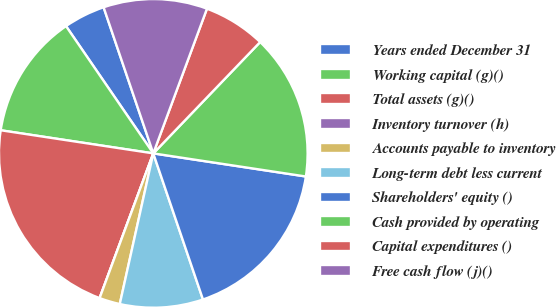Convert chart to OTSL. <chart><loc_0><loc_0><loc_500><loc_500><pie_chart><fcel>Years ended December 31<fcel>Working capital (g)()<fcel>Total assets (g)()<fcel>Inventory turnover (h)<fcel>Accounts payable to inventory<fcel>Long-term debt less current<fcel>Shareholders' equity ()<fcel>Cash provided by operating<fcel>Capital expenditures ()<fcel>Free cash flow (j)()<nl><fcel>4.35%<fcel>13.04%<fcel>21.74%<fcel>0.0%<fcel>2.17%<fcel>8.7%<fcel>17.39%<fcel>15.22%<fcel>6.52%<fcel>10.87%<nl></chart> 